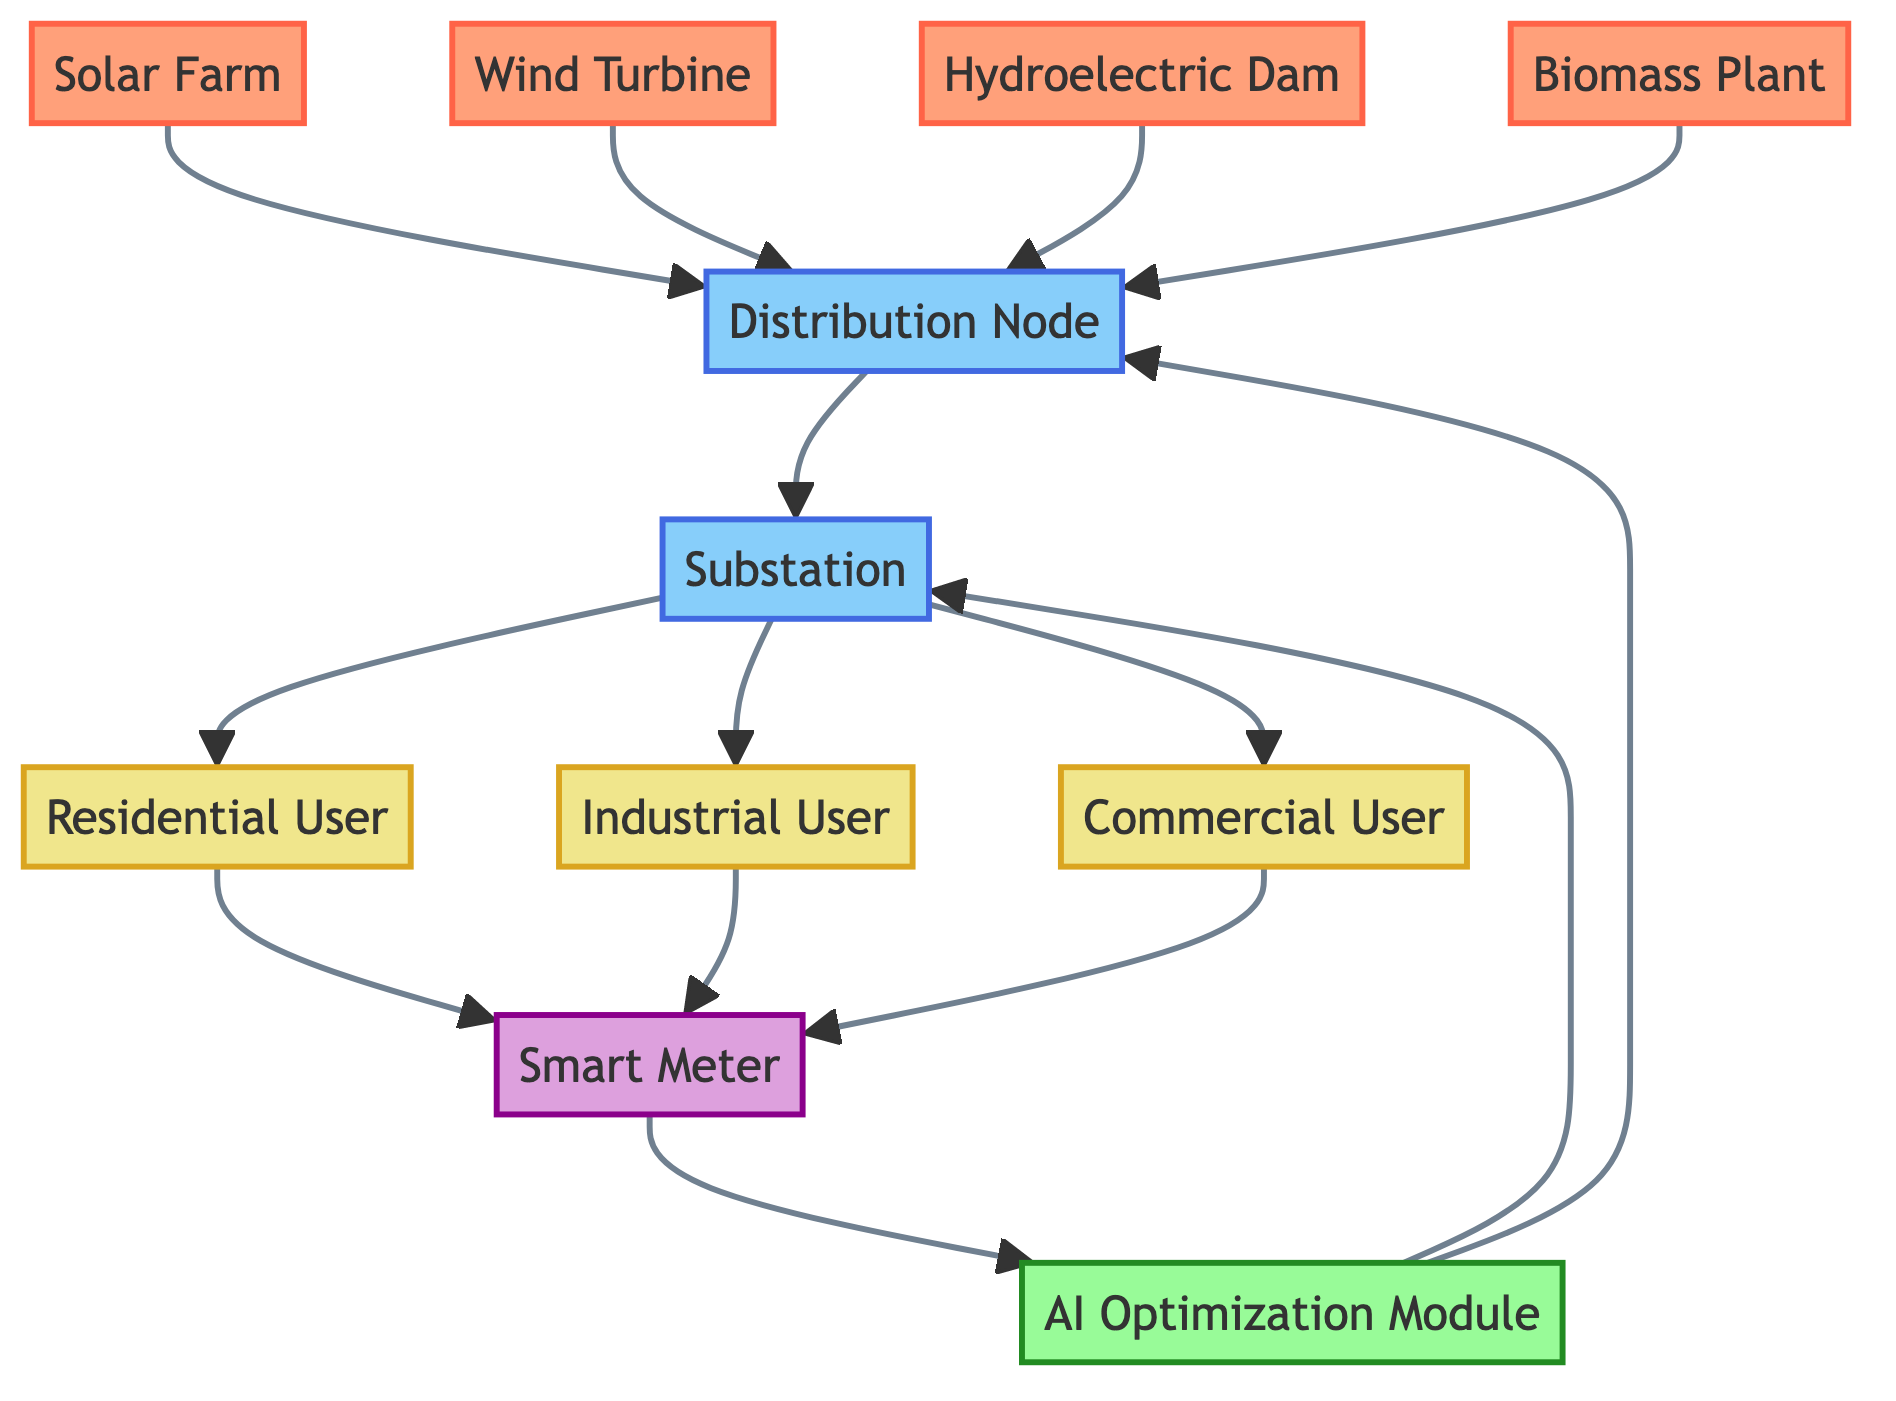What is the total number of energy sources in the diagram? The diagram includes nodes labeled Solar Farm, Wind Turbine, Hydroelectric Dam, and Biomass Plant. These are four distinct nodes identified as energy sources.
Answer: 4 How many types of end users are represented? There are three distinct end user nodes: Residential User, Industrial User, and Commercial User. Each represents a different category of electricity consumers.
Answer: 3 Which node is responsible for optimizing electricity distribution? The AI Optimization Module, labeled as ai_optimization, is specifically designed to optimize the electricity distribution processes depicted in the diagram.
Answer: AI Optimization Module What connects the Distribution Node to the Substation? The edges between these two nodes illustrate the transmission of electricity, specifically indicating that electricity flows from the Distribution Node to the Substation.
Answer: Electricity transmission Which energy source does not connect directly to an end user? The energy sources (Solar Farm, Wind Turbine, Hydroelectric Dam, and Biomass Plant) connect to the Distribution Node, which then connects to the Substation and ultimately to end users. Since the energy sources do not have direct connections to end users, they can be noted as not connecting directly.
Answer: All energy sources What role do Smart Meters play according to the diagram? Smart Meters gather and report electricity usage data from various end users and send this information to the AI Optimization Module for further analysis, connecting indirectly to the end users.
Answer: User equipment How many connections does the AI Optimization Module have? The AI Optimization Module has two connections: one to the Distribution Node and one to the Substation. These connections enable it to optimize the transmission and distribution of electricity.
Answer: 2 What kind of data do Smart Meters collect? Smart Meters collect electricity usage data from Residential, Industrial, and Commercial Users as indicated by their connections to these end user nodes.
Answer: Electricity usage data Which node does all energy sources connect to? All identified energy sources connect to the Distribution Node, serving as a central point for their electricity transmission to other network nodes.
Answer: Distribution Node What is the function of the Substation in the diagram? The Substation is designed to transform voltage levels before distributing electricity to the end users: Residential, Industrial, and Commercial Users. This role is critical for managing the safe and efficient flow of electricity.
Answer: Transforming voltage levels 